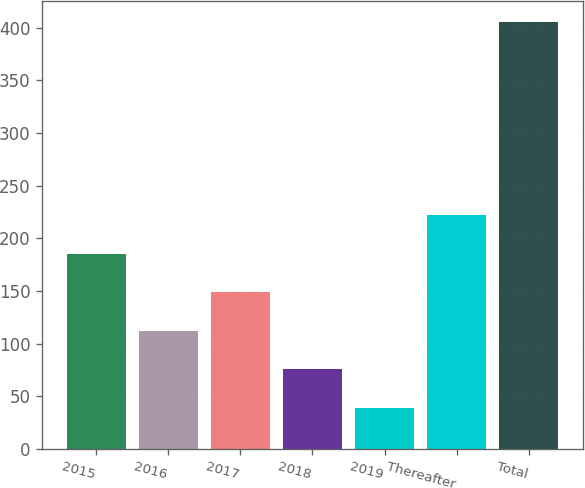<chart> <loc_0><loc_0><loc_500><loc_500><bar_chart><fcel>2015<fcel>2016<fcel>2017<fcel>2018<fcel>2019<fcel>Thereafter<fcel>Total<nl><fcel>185.4<fcel>112.2<fcel>148.8<fcel>75.6<fcel>39<fcel>222<fcel>405<nl></chart> 